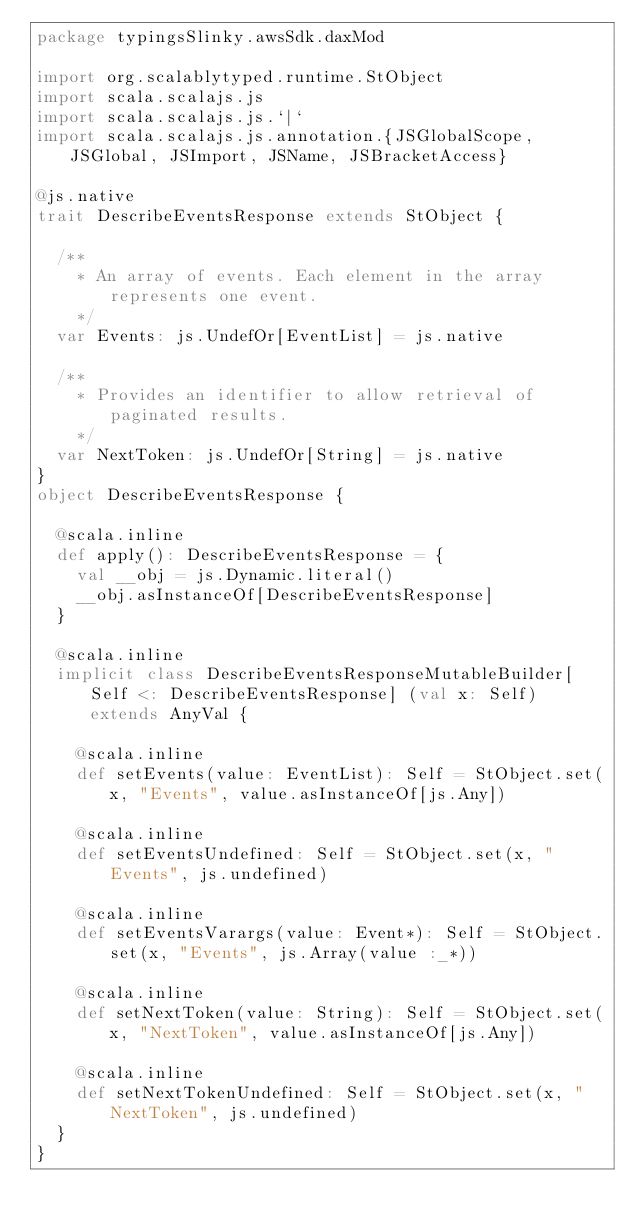<code> <loc_0><loc_0><loc_500><loc_500><_Scala_>package typingsSlinky.awsSdk.daxMod

import org.scalablytyped.runtime.StObject
import scala.scalajs.js
import scala.scalajs.js.`|`
import scala.scalajs.js.annotation.{JSGlobalScope, JSGlobal, JSImport, JSName, JSBracketAccess}

@js.native
trait DescribeEventsResponse extends StObject {
  
  /**
    * An array of events. Each element in the array represents one event.
    */
  var Events: js.UndefOr[EventList] = js.native
  
  /**
    * Provides an identifier to allow retrieval of paginated results.
    */
  var NextToken: js.UndefOr[String] = js.native
}
object DescribeEventsResponse {
  
  @scala.inline
  def apply(): DescribeEventsResponse = {
    val __obj = js.Dynamic.literal()
    __obj.asInstanceOf[DescribeEventsResponse]
  }
  
  @scala.inline
  implicit class DescribeEventsResponseMutableBuilder[Self <: DescribeEventsResponse] (val x: Self) extends AnyVal {
    
    @scala.inline
    def setEvents(value: EventList): Self = StObject.set(x, "Events", value.asInstanceOf[js.Any])
    
    @scala.inline
    def setEventsUndefined: Self = StObject.set(x, "Events", js.undefined)
    
    @scala.inline
    def setEventsVarargs(value: Event*): Self = StObject.set(x, "Events", js.Array(value :_*))
    
    @scala.inline
    def setNextToken(value: String): Self = StObject.set(x, "NextToken", value.asInstanceOf[js.Any])
    
    @scala.inline
    def setNextTokenUndefined: Self = StObject.set(x, "NextToken", js.undefined)
  }
}
</code> 